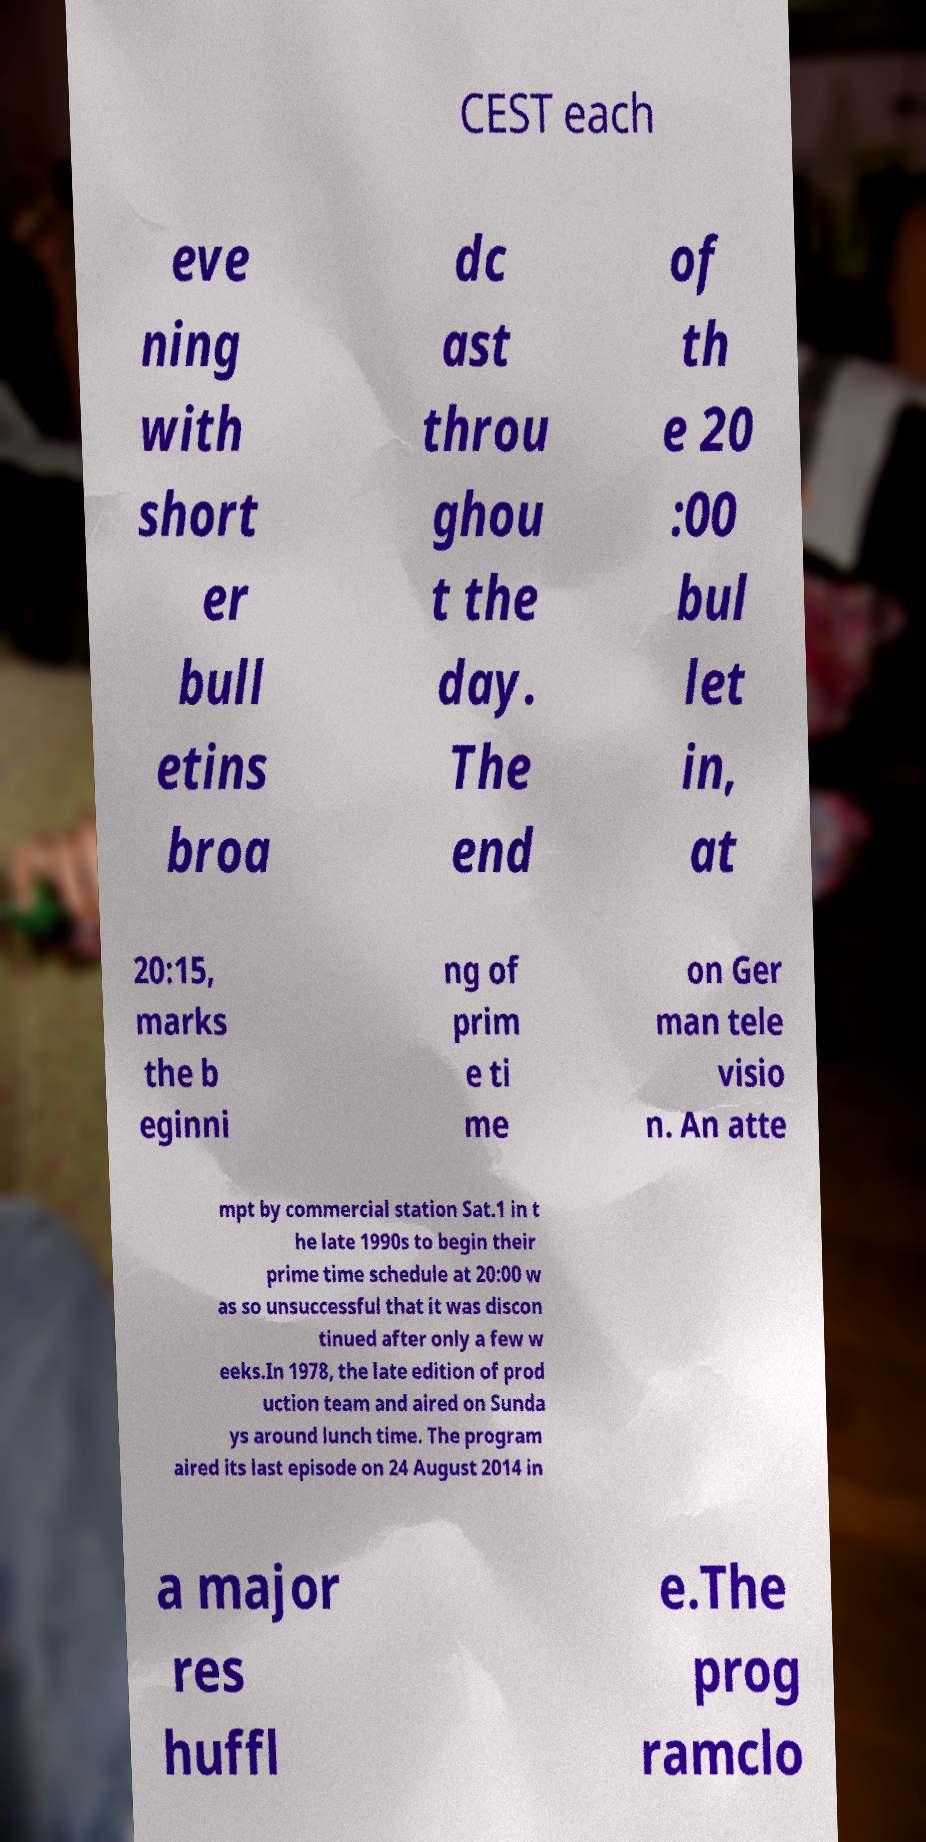I need the written content from this picture converted into text. Can you do that? CEST each eve ning with short er bull etins broa dc ast throu ghou t the day. The end of th e 20 :00 bul let in, at 20:15, marks the b eginni ng of prim e ti me on Ger man tele visio n. An atte mpt by commercial station Sat.1 in t he late 1990s to begin their prime time schedule at 20:00 w as so unsuccessful that it was discon tinued after only a few w eeks.In 1978, the late edition of prod uction team and aired on Sunda ys around lunch time. The program aired its last episode on 24 August 2014 in a major res huffl e.The prog ramclo 